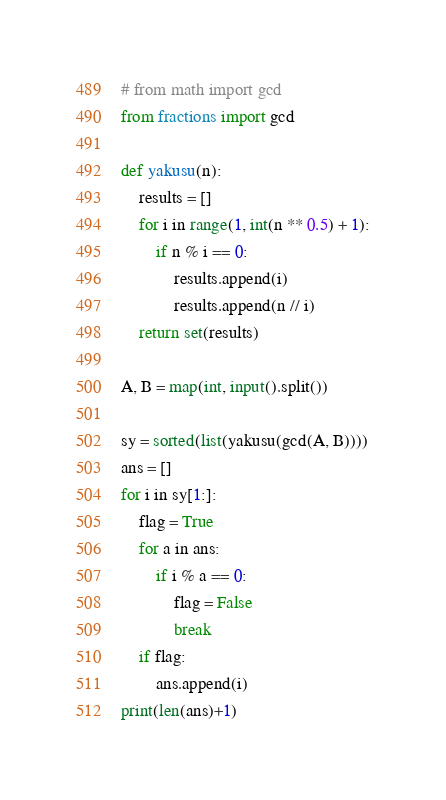<code> <loc_0><loc_0><loc_500><loc_500><_Python_># from math import gcd
from fractions import gcd

def yakusu(n):
    results = []
    for i in range(1, int(n ** 0.5) + 1):
        if n % i == 0:
            results.append(i)
            results.append(n // i)
    return set(results)

A, B = map(int, input().split())

sy = sorted(list(yakusu(gcd(A, B))))
ans = []
for i in sy[1:]:
    flag = True
    for a in ans:
        if i % a == 0:
            flag = False
            break
    if flag:
        ans.append(i)
print(len(ans)+1)</code> 